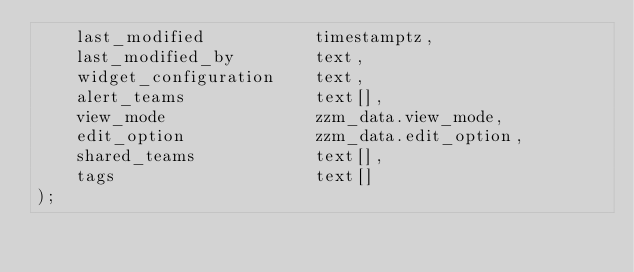Convert code to text. <code><loc_0><loc_0><loc_500><loc_500><_SQL_>    last_modified           timestamptz,
    last_modified_by        text,
    widget_configuration    text,
    alert_teams             text[],
    view_mode               zzm_data.view_mode,
    edit_option             zzm_data.edit_option,
    shared_teams            text[],
    tags                    text[]
);
</code> 